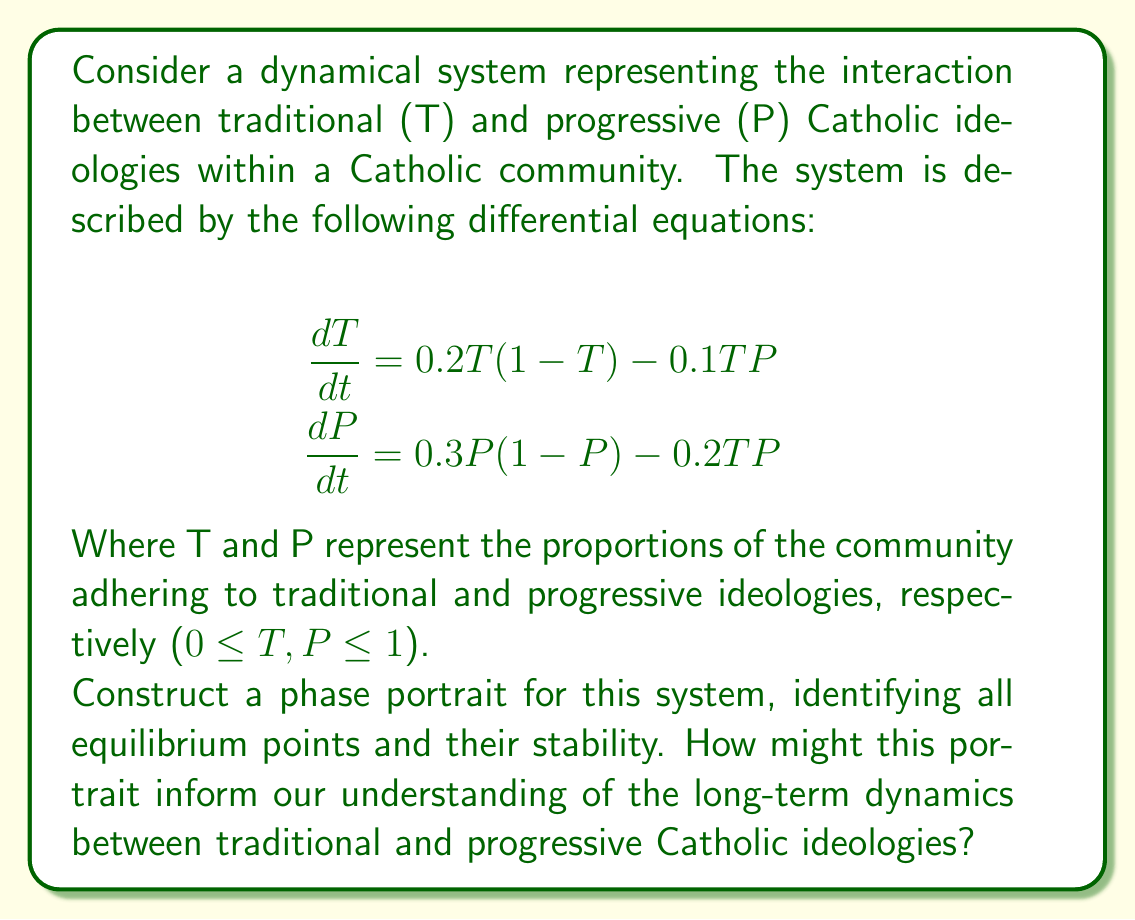Help me with this question. To construct the phase portrait and analyze the dynamical system, we'll follow these steps:

1. Find the nullclines:
   T-nullcline: $0.2T(1-T) - 0.1TP = 0$
   P-nullcline: $0.3P(1-P) - 0.2TP = 0$

2. Solve for the equilibrium points by finding the intersections of the nullclines:
   a) (0, 0): Trivial equilibrium
   b) (1, 0): Only traditional ideology
   c) (0, 1): Only progressive ideology
   d) Solving the system of equations:
      $0.2(1-T) = 0.1P$
      $0.3(1-P) = 0.2T$
      We get: $(T^*, P^*) \approx (0.5455, 0.6364)$

3. Analyze the stability of each equilibrium point by calculating the Jacobian matrix:
   $$J = \begin{bmatrix}
   0.2 - 0.4T - 0.1P & -0.1T \\
   -0.2P & 0.3 - 0.6P - 0.2T
   \end{bmatrix}$$

   Evaluate the Jacobian at each equilibrium point and determine the eigenvalues:
   a) (0, 0): Unstable node
   b) (1, 0): Saddle point
   c) (0, 1): Saddle point
   d) (0.5455, 0.6364): Stable node

4. Sketch the phase portrait:
   [asy]
   import graph;
   size(200);
   
   real f(real x, real y) { return 0.2*x*(1-x) - 0.1*x*y; }
   real g(real x, real y) { return 0.3*y*(1-y) - 0.2*x*y; }
   
   add(vectorfield((x,y) => (f(x,y), g(x,y)), (0,0), (1,1), 15, 15, blue));
   
   dot((0,0));
   dot((1,0));
   dot((0,1));
   dot((0.5455,0.6364), red);
   
   xaxis("T", Arrow);
   yaxis("P", Arrow);
   
   label("(0,0)", (0,0), SW);
   label("(1,0)", (1,0), SE);
   label("(0,1)", (0,1), NW);
   label("(T*,P*)", (0.5455,0.6364), NE);
   [/asy]

5. Interpret the phase portrait:
   - The stable equilibrium (T*, P*) suggests a long-term coexistence of traditional and progressive ideologies.
   - Trajectories starting near (0,0), (1,0), or (0,1) will eventually move towards (T*, P*).
   - The system tends to avoid extremes, favoring a balanced state between traditional and progressive views.

This phase portrait informs us that, in the long term, the Catholic community is likely to settle into a state where both traditional and progressive ideologies coexist, rather than one completely dominating the other. This insight can guide efforts for internal reform and dialogue within the Church.
Answer: The phase portrait shows four equilibrium points: (0,0) unstable node, (1,0) and (0,1) saddle points, and (T*,P*) ≈ (0.5455, 0.6364) stable node. The system tends towards a balanced coexistence of traditional and progressive ideologies. 